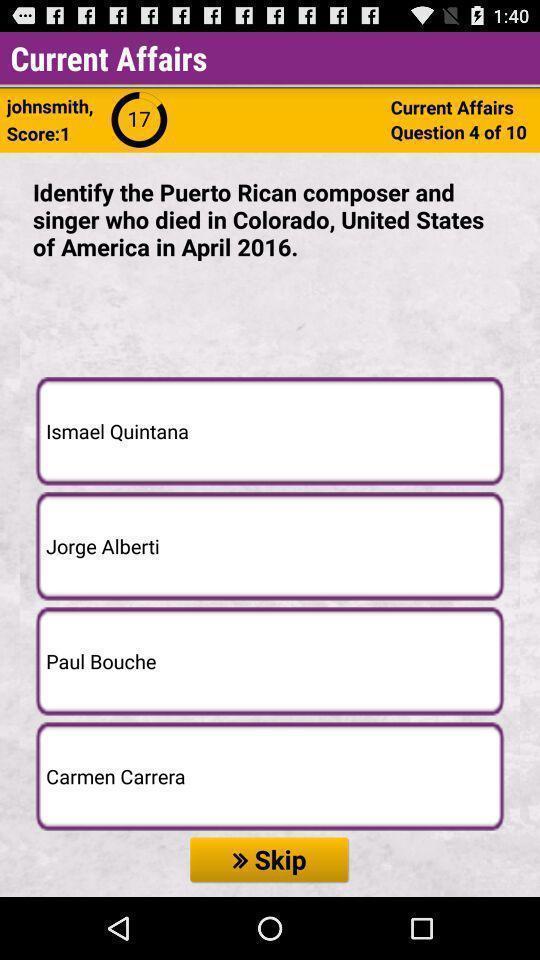Tell me what you see in this picture. Page shows question about current affairs. 